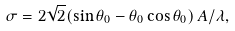<formula> <loc_0><loc_0><loc_500><loc_500>\sigma = 2 \sqrt { 2 } ( \sin \theta _ { 0 } - \theta _ { 0 } \cos \theta _ { 0 } ) \, A / \lambda ,</formula> 